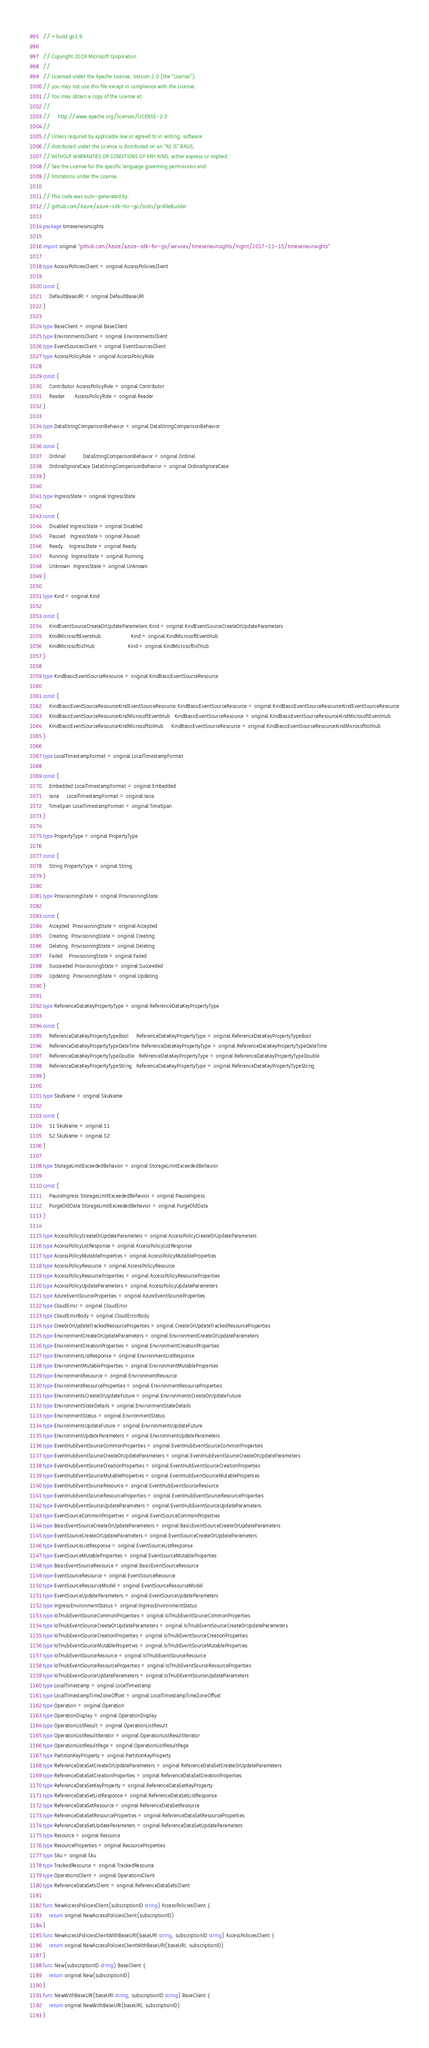Convert code to text. <code><loc_0><loc_0><loc_500><loc_500><_Go_>// +build go1.9

// Copyright 2019 Microsoft Corporation
//
// Licensed under the Apache License, Version 2.0 (the "License");
// you may not use this file except in compliance with the License.
// You may obtain a copy of the License at
//
//     http://www.apache.org/licenses/LICENSE-2.0
//
// Unless required by applicable law or agreed to in writing, software
// distributed under the License is distributed on an "AS IS" BASIS,
// WITHOUT WARRANTIES OR CONDITIONS OF ANY KIND, either express or implied.
// See the License for the specific language governing permissions and
// limitations under the License.

// This code was auto-generated by:
// github.com/Azure/azure-sdk-for-go/tools/profileBuilder

package timeseriesinsights

import original "github.com/Azure/azure-sdk-for-go/services/timeseriesinsights/mgmt/2017-11-15/timeseriesinsights"

type AccessPoliciesClient = original.AccessPoliciesClient

const (
	DefaultBaseURI = original.DefaultBaseURI
)

type BaseClient = original.BaseClient
type EnvironmentsClient = original.EnvironmentsClient
type EventSourcesClient = original.EventSourcesClient
type AccessPolicyRole = original.AccessPolicyRole

const (
	Contributor AccessPolicyRole = original.Contributor
	Reader      AccessPolicyRole = original.Reader
)

type DataStringComparisonBehavior = original.DataStringComparisonBehavior

const (
	Ordinal           DataStringComparisonBehavior = original.Ordinal
	OrdinalIgnoreCase DataStringComparisonBehavior = original.OrdinalIgnoreCase
)

type IngressState = original.IngressState

const (
	Disabled IngressState = original.Disabled
	Paused   IngressState = original.Paused
	Ready    IngressState = original.Ready
	Running  IngressState = original.Running
	Unknown  IngressState = original.Unknown
)

type Kind = original.Kind

const (
	KindEventSourceCreateOrUpdateParameters Kind = original.KindEventSourceCreateOrUpdateParameters
	KindMicrosoftEventHub                   Kind = original.KindMicrosoftEventHub
	KindMicrosoftIoTHub                     Kind = original.KindMicrosoftIoTHub
)

type KindBasicEventSourceResource = original.KindBasicEventSourceResource

const (
	KindBasicEventSourceResourceKindEventSourceResource KindBasicEventSourceResource = original.KindBasicEventSourceResourceKindEventSourceResource
	KindBasicEventSourceResourceKindMicrosoftEventHub   KindBasicEventSourceResource = original.KindBasicEventSourceResourceKindMicrosoftEventHub
	KindBasicEventSourceResourceKindMicrosoftIotHub     KindBasicEventSourceResource = original.KindBasicEventSourceResourceKindMicrosoftIotHub
)

type LocalTimestampFormat = original.LocalTimestampFormat

const (
	Embedded LocalTimestampFormat = original.Embedded
	Iana     LocalTimestampFormat = original.Iana
	TimeSpan LocalTimestampFormat = original.TimeSpan
)

type PropertyType = original.PropertyType

const (
	String PropertyType = original.String
)

type ProvisioningState = original.ProvisioningState

const (
	Accepted  ProvisioningState = original.Accepted
	Creating  ProvisioningState = original.Creating
	Deleting  ProvisioningState = original.Deleting
	Failed    ProvisioningState = original.Failed
	Succeeded ProvisioningState = original.Succeeded
	Updating  ProvisioningState = original.Updating
)

type ReferenceDataKeyPropertyType = original.ReferenceDataKeyPropertyType

const (
	ReferenceDataKeyPropertyTypeBool     ReferenceDataKeyPropertyType = original.ReferenceDataKeyPropertyTypeBool
	ReferenceDataKeyPropertyTypeDateTime ReferenceDataKeyPropertyType = original.ReferenceDataKeyPropertyTypeDateTime
	ReferenceDataKeyPropertyTypeDouble   ReferenceDataKeyPropertyType = original.ReferenceDataKeyPropertyTypeDouble
	ReferenceDataKeyPropertyTypeString   ReferenceDataKeyPropertyType = original.ReferenceDataKeyPropertyTypeString
)

type SkuName = original.SkuName

const (
	S1 SkuName = original.S1
	S2 SkuName = original.S2
)

type StorageLimitExceededBehavior = original.StorageLimitExceededBehavior

const (
	PauseIngress StorageLimitExceededBehavior = original.PauseIngress
	PurgeOldData StorageLimitExceededBehavior = original.PurgeOldData
)

type AccessPolicyCreateOrUpdateParameters = original.AccessPolicyCreateOrUpdateParameters
type AccessPolicyListResponse = original.AccessPolicyListResponse
type AccessPolicyMutableProperties = original.AccessPolicyMutableProperties
type AccessPolicyResource = original.AccessPolicyResource
type AccessPolicyResourceProperties = original.AccessPolicyResourceProperties
type AccessPolicyUpdateParameters = original.AccessPolicyUpdateParameters
type AzureEventSourceProperties = original.AzureEventSourceProperties
type CloudError = original.CloudError
type CloudErrorBody = original.CloudErrorBody
type CreateOrUpdateTrackedResourceProperties = original.CreateOrUpdateTrackedResourceProperties
type EnvironmentCreateOrUpdateParameters = original.EnvironmentCreateOrUpdateParameters
type EnvironmentCreationProperties = original.EnvironmentCreationProperties
type EnvironmentListResponse = original.EnvironmentListResponse
type EnvironmentMutableProperties = original.EnvironmentMutableProperties
type EnvironmentResource = original.EnvironmentResource
type EnvironmentResourceProperties = original.EnvironmentResourceProperties
type EnvironmentsCreateOrUpdateFuture = original.EnvironmentsCreateOrUpdateFuture
type EnvironmentStateDetails = original.EnvironmentStateDetails
type EnvironmentStatus = original.EnvironmentStatus
type EnvironmentsUpdateFuture = original.EnvironmentsUpdateFuture
type EnvironmentUpdateParameters = original.EnvironmentUpdateParameters
type EventHubEventSourceCommonProperties = original.EventHubEventSourceCommonProperties
type EventHubEventSourceCreateOrUpdateParameters = original.EventHubEventSourceCreateOrUpdateParameters
type EventHubEventSourceCreationProperties = original.EventHubEventSourceCreationProperties
type EventHubEventSourceMutableProperties = original.EventHubEventSourceMutableProperties
type EventHubEventSourceResource = original.EventHubEventSourceResource
type EventHubEventSourceResourceProperties = original.EventHubEventSourceResourceProperties
type EventHubEventSourceUpdateParameters = original.EventHubEventSourceUpdateParameters
type EventSourceCommonProperties = original.EventSourceCommonProperties
type BasicEventSourceCreateOrUpdateParameters = original.BasicEventSourceCreateOrUpdateParameters
type EventSourceCreateOrUpdateParameters = original.EventSourceCreateOrUpdateParameters
type EventSourceListResponse = original.EventSourceListResponse
type EventSourceMutableProperties = original.EventSourceMutableProperties
type BasicEventSourceResource = original.BasicEventSourceResource
type EventSourceResource = original.EventSourceResource
type EventSourceResourceModel = original.EventSourceResourceModel
type EventSourceUpdateParameters = original.EventSourceUpdateParameters
type IngressEnvironmentStatus = original.IngressEnvironmentStatus
type IoTHubEventSourceCommonProperties = original.IoTHubEventSourceCommonProperties
type IoTHubEventSourceCreateOrUpdateParameters = original.IoTHubEventSourceCreateOrUpdateParameters
type IoTHubEventSourceCreationProperties = original.IoTHubEventSourceCreationProperties
type IoTHubEventSourceMutableProperties = original.IoTHubEventSourceMutableProperties
type IoTHubEventSourceResource = original.IoTHubEventSourceResource
type IoTHubEventSourceResourceProperties = original.IoTHubEventSourceResourceProperties
type IoTHubEventSourceUpdateParameters = original.IoTHubEventSourceUpdateParameters
type LocalTimestamp = original.LocalTimestamp
type LocalTimestampTimeZoneOffset = original.LocalTimestampTimeZoneOffset
type Operation = original.Operation
type OperationDisplay = original.OperationDisplay
type OperationListResult = original.OperationListResult
type OperationListResultIterator = original.OperationListResultIterator
type OperationListResultPage = original.OperationListResultPage
type PartitionKeyProperty = original.PartitionKeyProperty
type ReferenceDataSetCreateOrUpdateParameters = original.ReferenceDataSetCreateOrUpdateParameters
type ReferenceDataSetCreationProperties = original.ReferenceDataSetCreationProperties
type ReferenceDataSetKeyProperty = original.ReferenceDataSetKeyProperty
type ReferenceDataSetListResponse = original.ReferenceDataSetListResponse
type ReferenceDataSetResource = original.ReferenceDataSetResource
type ReferenceDataSetResourceProperties = original.ReferenceDataSetResourceProperties
type ReferenceDataSetUpdateParameters = original.ReferenceDataSetUpdateParameters
type Resource = original.Resource
type ResourceProperties = original.ResourceProperties
type Sku = original.Sku
type TrackedResource = original.TrackedResource
type OperationsClient = original.OperationsClient
type ReferenceDataSetsClient = original.ReferenceDataSetsClient

func NewAccessPoliciesClient(subscriptionID string) AccessPoliciesClient {
	return original.NewAccessPoliciesClient(subscriptionID)
}
func NewAccessPoliciesClientWithBaseURI(baseURI string, subscriptionID string) AccessPoliciesClient {
	return original.NewAccessPoliciesClientWithBaseURI(baseURI, subscriptionID)
}
func New(subscriptionID string) BaseClient {
	return original.New(subscriptionID)
}
func NewWithBaseURI(baseURI string, subscriptionID string) BaseClient {
	return original.NewWithBaseURI(baseURI, subscriptionID)
}</code> 